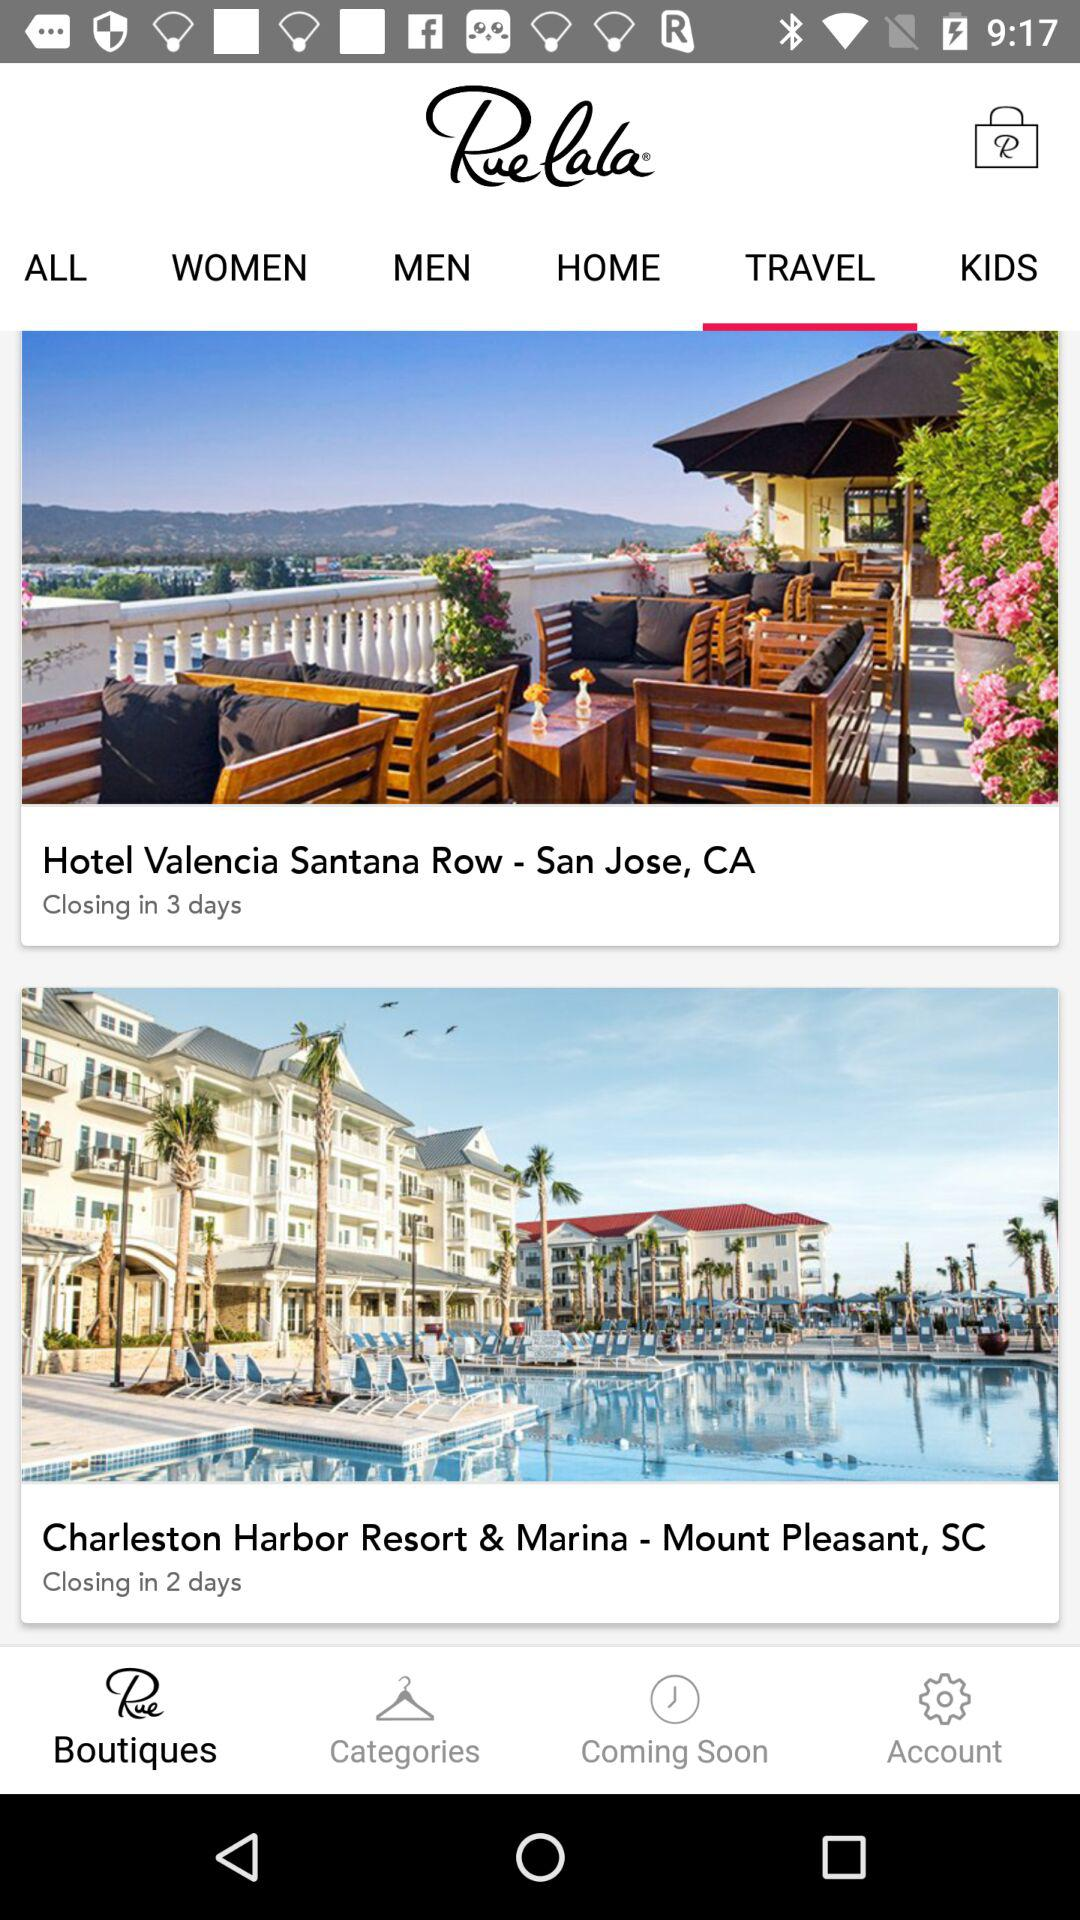Which tab is open? The open tabs are "Boutiques" and "TRAVEL". 